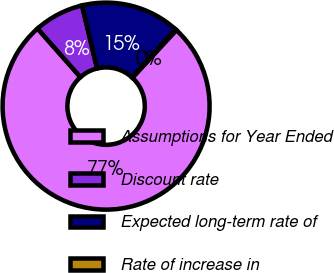Convert chart. <chart><loc_0><loc_0><loc_500><loc_500><pie_chart><fcel>Assumptions for Year Ended<fcel>Discount rate<fcel>Expected long-term rate of<fcel>Rate of increase in<nl><fcel>76.62%<fcel>7.79%<fcel>15.44%<fcel>0.15%<nl></chart> 